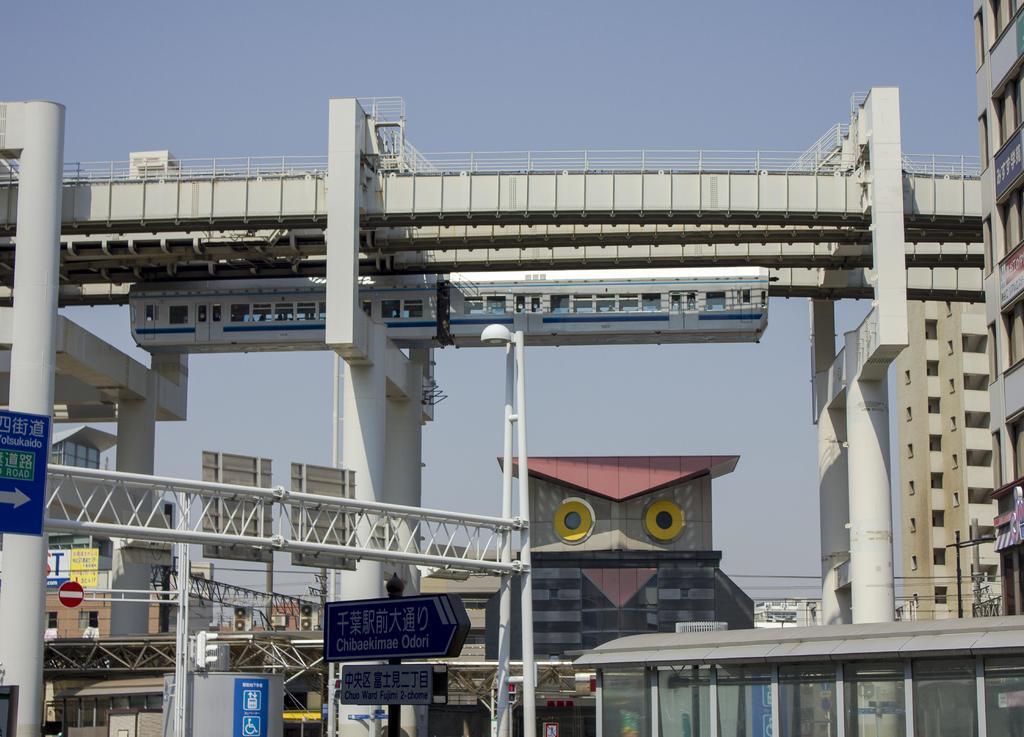In one or two sentences, can you explain what this image depicts? In the foreground of the image we can see iron rods and a board on which some text is written. In the middle of the image we can see buildings and pillars. On the top of the image we can see the sky. 